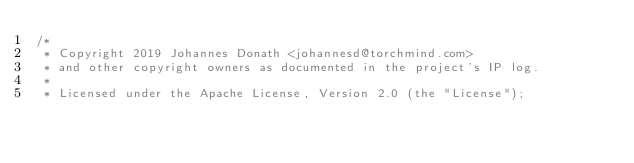<code> <loc_0><loc_0><loc_500><loc_500><_Kotlin_>/*
 * Copyright 2019 Johannes Donath <johannesd@torchmind.com>
 * and other copyright owners as documented in the project's IP log.
 *
 * Licensed under the Apache License, Version 2.0 (the "License");</code> 